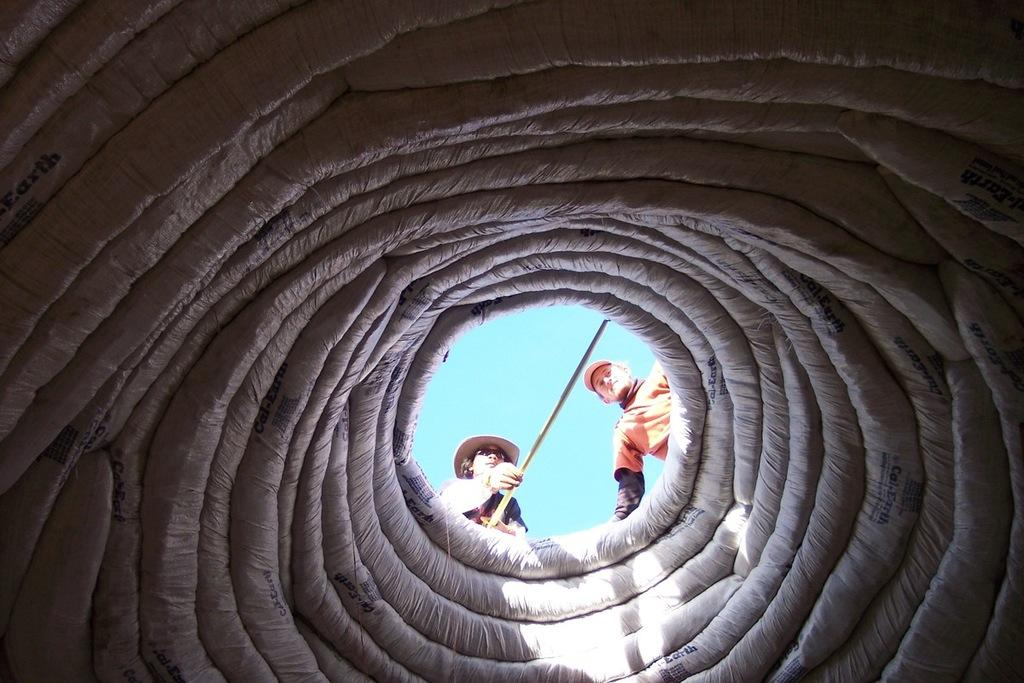What is the shape of the object in the image? The object in the image is circular. How many people are present in the image? There are two persons in the image. What can be seen in the image besides the persons and the circular object? There is a stick in the image. What is visible in the background of the image? The sky is visible in the image. Can you determine the time of day when the image was taken? The image was likely taken during the day, as the sky is visible. Did the persons in the image experience an earthquake while holding the stick? There is no indication of an earthquake or any related activity in the image. 